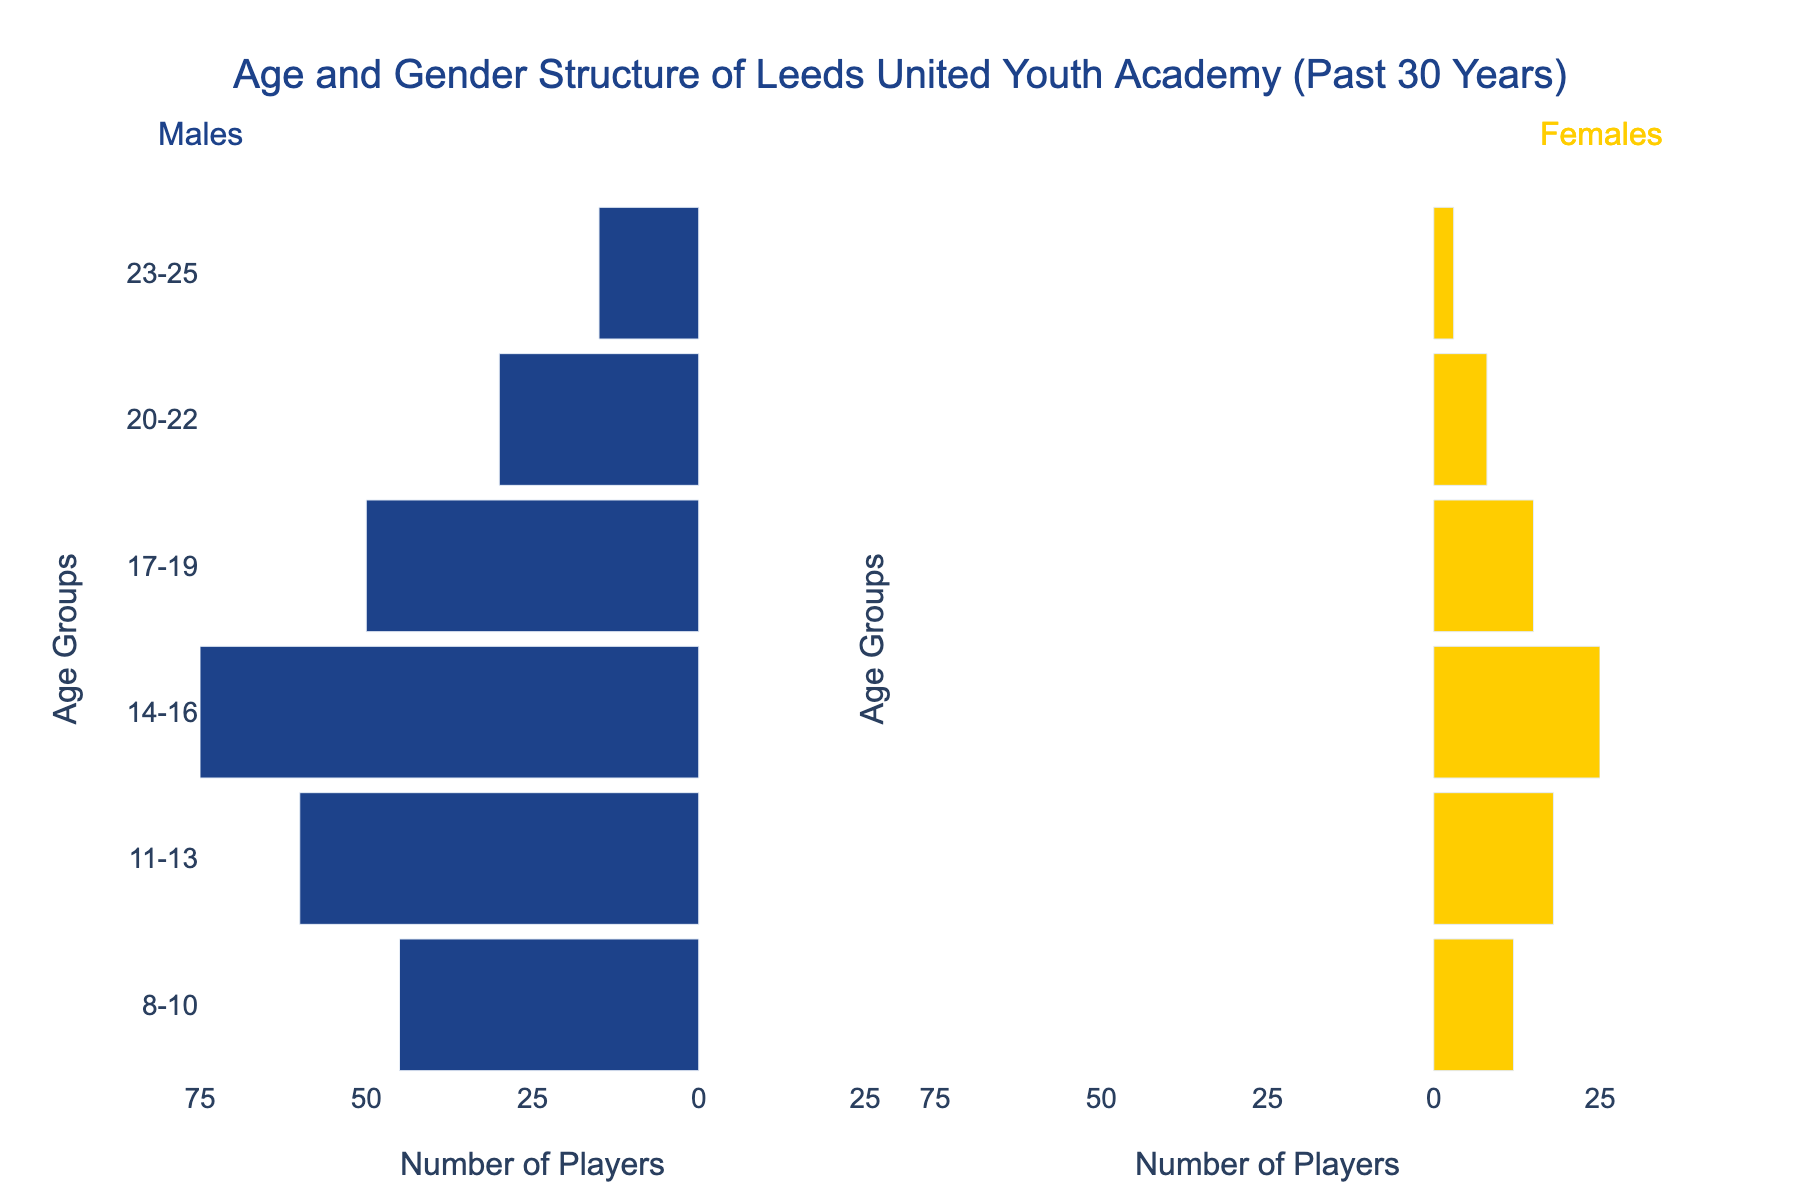what's the title of the figure? The title is displayed at the top of the figure. It reads, "Age and Gender Structure of Leeds United Youth Academy (Past 30 Years)."
Answer: Age and Gender Structure of Leeds United Youth Academy (Past 30 Years) how many players are in the age group 8-10 for males and females combined? For the age group 8-10, you need to sum up the number of males and females. The figure shows 45 males and 12 females, giving a total of 45 + 12 = 57 players.
Answer: 57 which age group has the highest number of male players? The figure shows the number of male players in each age group with bars on the left. The age group with the longest bar, indicating the highest number, is 14-16 with 75 players.
Answer: 14-16 what's the difference between the number of male and female players in the 17-19 age group? The figure indicates 50 males and 15 females in the 17-19 age group. The difference is found by subtracting the number of females from males: 50 - 15 = 35.
Answer: 35 which gender has fewer players in the age group 20-22? Look at the bars for the age group 20-22. The female bar is shorter and shows 8 players compared to 30 males, indicating fewer female players.
Answer: Females how many total youth academy players are there across all age groups? Sum the total number of male and female players across all age groups. For males: 45 + 60 + 75 + 50 + 30 + 15 = 275. For females: 12 + 18 + 25 + 15 + 8 + 3 = 81. The total is 275 (males) + 81 (females) = 356.
Answer: 356 which age group has an equal number of male and female players or the closest to being equal? Compare the male and female figures for each age group. No age group has an equal number, but the age group 17-19 has relatively closer numbers with 50 males and 15 females, a difference of 35, compared to other age groups where the gaps are larger.
Answer: 17-19 what is the average number of male players per age group? Sum up the total male players (275) and divide by the number of age groups (6). So, 275 / 6 ≈ 45.83.
Answer: 45.83 how much larger is the number of players in the age group 14-16 compared to the age group 23-25? Sum the number of players in each age group. For 14-16: 75 (males) + 25 (females) = 100. For 23-25: 15 (males) + 3 (females) = 18. The difference is 100 - 18 = 82.
Answer: 82 